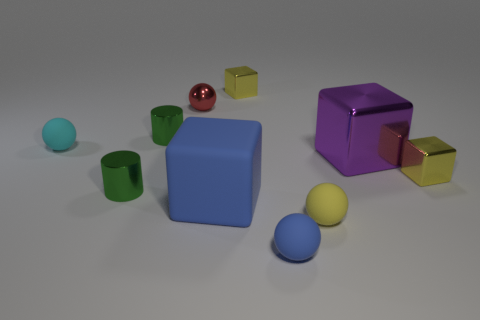How many yellow cubes must be subtracted to get 1 yellow cubes? 1 Subtract 1 balls. How many balls are left? 3 Subtract all purple metallic cubes. How many cubes are left? 3 Subtract all blue balls. How many balls are left? 3 Subtract all brown cubes. Subtract all blue balls. How many cubes are left? 4 Subtract all blocks. How many objects are left? 6 Subtract all tiny red shiny balls. Subtract all cyan spheres. How many objects are left? 8 Add 1 yellow metal objects. How many yellow metal objects are left? 3 Add 6 big metallic blocks. How many big metallic blocks exist? 7 Subtract 1 yellow spheres. How many objects are left? 9 